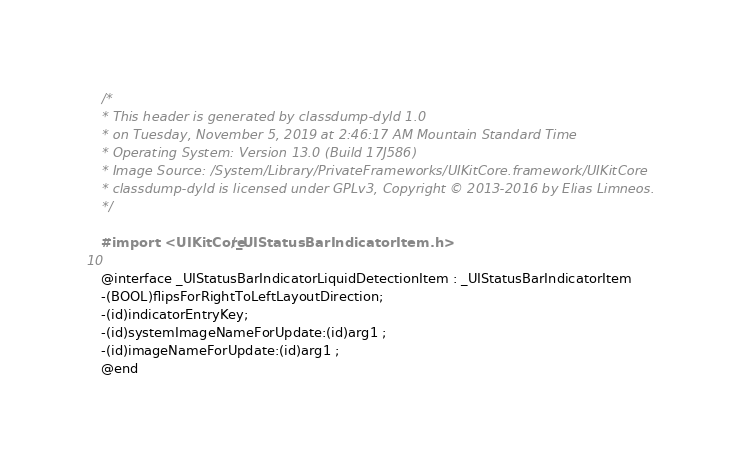<code> <loc_0><loc_0><loc_500><loc_500><_C_>/*
* This header is generated by classdump-dyld 1.0
* on Tuesday, November 5, 2019 at 2:46:17 AM Mountain Standard Time
* Operating System: Version 13.0 (Build 17J586)
* Image Source: /System/Library/PrivateFrameworks/UIKitCore.framework/UIKitCore
* classdump-dyld is licensed under GPLv3, Copyright © 2013-2016 by Elias Limneos.
*/

#import <UIKitCore/_UIStatusBarIndicatorItem.h>

@interface _UIStatusBarIndicatorLiquidDetectionItem : _UIStatusBarIndicatorItem
-(BOOL)flipsForRightToLeftLayoutDirection;
-(id)indicatorEntryKey;
-(id)systemImageNameForUpdate:(id)arg1 ;
-(id)imageNameForUpdate:(id)arg1 ;
@end

</code> 